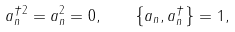Convert formula to latex. <formula><loc_0><loc_0><loc_500><loc_500>a ^ { \dagger 2 } _ { n } = a ^ { 2 } _ { n } = 0 , \quad \left \{ a _ { n } , a ^ { \dagger } _ { n } \right \} = 1 ,</formula> 